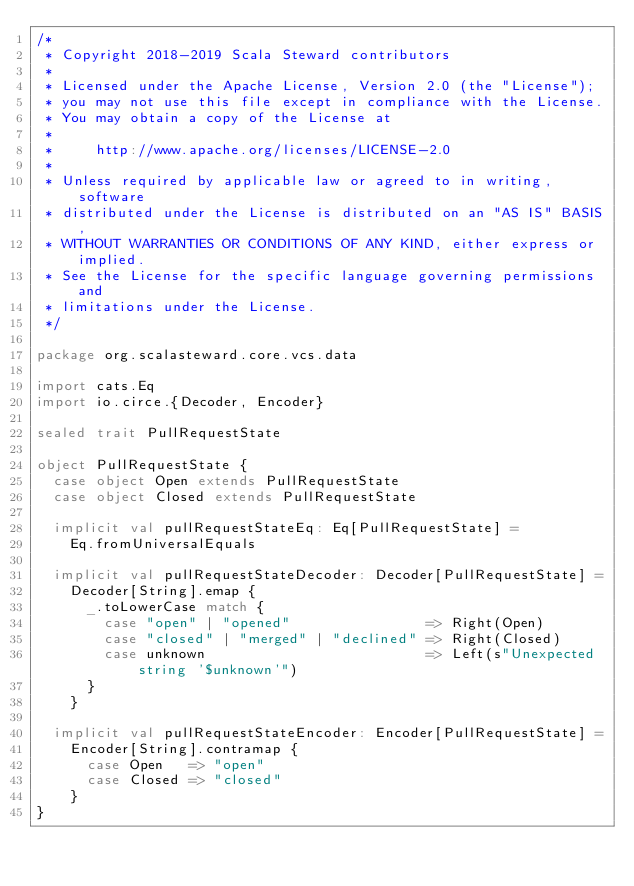<code> <loc_0><loc_0><loc_500><loc_500><_Scala_>/*
 * Copyright 2018-2019 Scala Steward contributors
 *
 * Licensed under the Apache License, Version 2.0 (the "License");
 * you may not use this file except in compliance with the License.
 * You may obtain a copy of the License at
 *
 *     http://www.apache.org/licenses/LICENSE-2.0
 *
 * Unless required by applicable law or agreed to in writing, software
 * distributed under the License is distributed on an "AS IS" BASIS,
 * WITHOUT WARRANTIES OR CONDITIONS OF ANY KIND, either express or implied.
 * See the License for the specific language governing permissions and
 * limitations under the License.
 */

package org.scalasteward.core.vcs.data

import cats.Eq
import io.circe.{Decoder, Encoder}

sealed trait PullRequestState

object PullRequestState {
  case object Open extends PullRequestState
  case object Closed extends PullRequestState

  implicit val pullRequestStateEq: Eq[PullRequestState] =
    Eq.fromUniversalEquals

  implicit val pullRequestStateDecoder: Decoder[PullRequestState] =
    Decoder[String].emap {
      _.toLowerCase match {
        case "open" | "opened"                => Right(Open)
        case "closed" | "merged" | "declined" => Right(Closed)
        case unknown                          => Left(s"Unexpected string '$unknown'")
      }
    }

  implicit val pullRequestStateEncoder: Encoder[PullRequestState] =
    Encoder[String].contramap {
      case Open   => "open"
      case Closed => "closed"
    }
}
</code> 